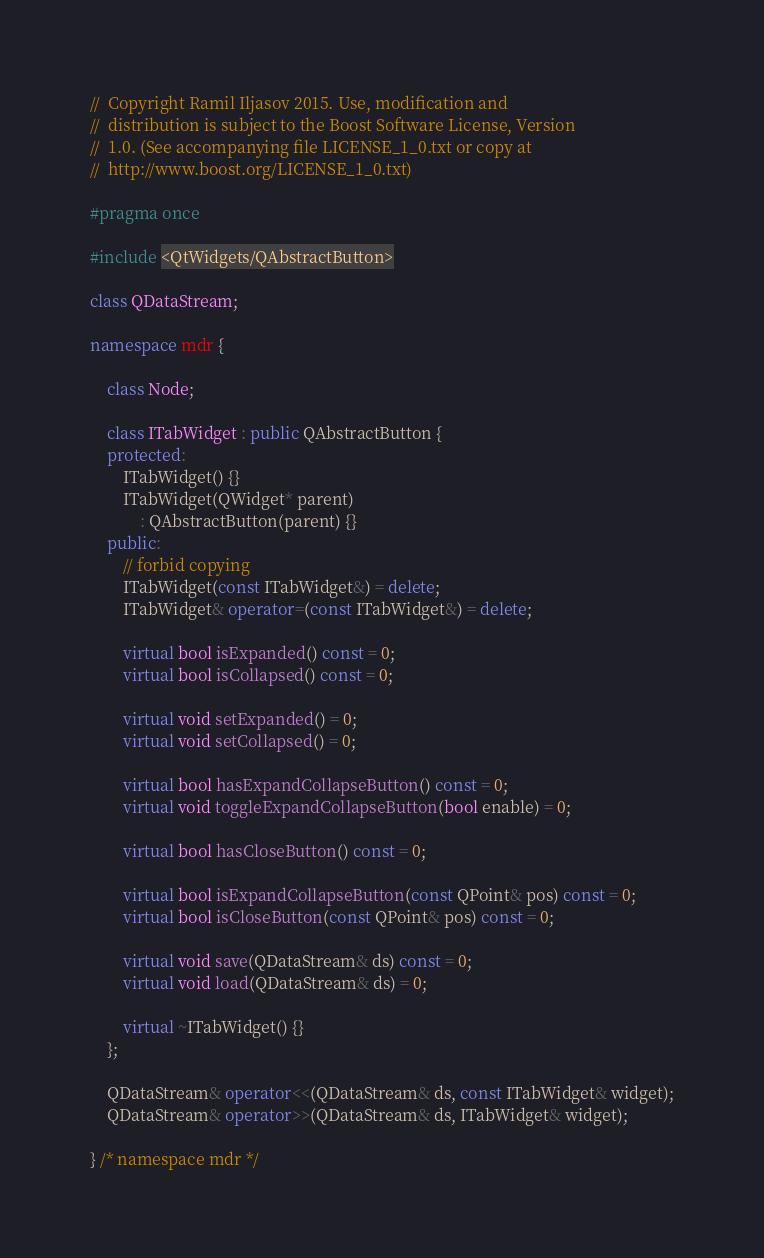Convert code to text. <code><loc_0><loc_0><loc_500><loc_500><_C++_>//  Copyright Ramil Iljasov 2015. Use, modification and
//  distribution is subject to the Boost Software License, Version
//  1.0. (See accompanying file LICENSE_1_0.txt or copy at
//  http://www.boost.org/LICENSE_1_0.txt)

#pragma once

#include <QtWidgets/QAbstractButton>

class QDataStream;

namespace mdr {

    class Node;

    class ITabWidget : public QAbstractButton {
    protected:
        ITabWidget() {}
        ITabWidget(QWidget* parent)
            : QAbstractButton(parent) {}
    public:
        // forbid copying
        ITabWidget(const ITabWidget&) = delete;
        ITabWidget& operator=(const ITabWidget&) = delete;

        virtual bool isExpanded() const = 0;
        virtual bool isCollapsed() const = 0;

        virtual void setExpanded() = 0;
        virtual void setCollapsed() = 0;

        virtual bool hasExpandCollapseButton() const = 0;
        virtual void toggleExpandCollapseButton(bool enable) = 0;

        virtual bool hasCloseButton() const = 0;

        virtual bool isExpandCollapseButton(const QPoint& pos) const = 0;
        virtual bool isCloseButton(const QPoint& pos) const = 0;

        virtual void save(QDataStream& ds) const = 0;
        virtual void load(QDataStream& ds) = 0;

        virtual ~ITabWidget() {}
    };

    QDataStream& operator<<(QDataStream& ds, const ITabWidget& widget);
    QDataStream& operator>>(QDataStream& ds, ITabWidget& widget);

} /* namespace mdr */
</code> 